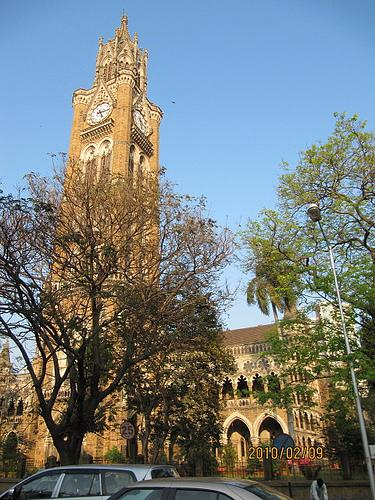Identify the main objects visible in the image and their colors. A blue sky with white clouds, a large tree to the right, a clock tower with a brown clock, a man wearing a white shirt, a red and white sign with the number 25, silver cars and a brick wall in front of a building. Describe any numbers present in the image and their context. There is the number 25 on a red and white sign and the date 20100209, which is a date stamp on the picture. What is the main action taking place in the image? Include the subject and their activity. A man in a white shirt is bending down in front of a building, near a sign with the number 25. Describe the tree that appears in the image, focusing on its position and size. There is a large tree to the right of the image, partially visible with a thick stem. Point out three architectural elements in the image and their respective colors. The clock tower is brown, the brick wall is red and the large arches on the building are gray. How would you describe the weather in this image? The weather seems to be pleasant, with a blue sky filled with white clouds. What color is the shirt worn by the man in the image? The man is wearing a white shirt. Describe the scene captured in the image focusing on the background elements. The image shows a blue sky with white clouds, a large tree beside a building, and the roof of the building. There is also a clock tower with a clock and a date stamp. From the provided information, what is the date mentioned in the image? The date mentioned in the image is 20100209. Read the text visible on the image at position X:247 Y:447 Width:77 Height:77. The date is 20100209. What is the color of the man's shirt at X:310 Y:477 Width:15 Height:15? White Explain the relationship between the clock and brick wall in the picture. The clock is on top of the building with a brick wall in front of it. Describe one significant detail that is mentioned about the cars in the image. These cars are silver. Describe any anomalies or unusual elements in the image. There are no significant anomalies or unusual elements. Where is the number "25" mentioned in the image? The number 25 is in red on the sign at X:121 Y:424 Width:10 Height:10. How would you describe the scene in this image? A street scene with cars driving by, a clock tower, a tall street lamp, and trees. Is there a person in the image? If yes, what are they doing? Yes, there is a man in a white shirt bending down in front of the building. Predict the interaction happening between the cars and the street lamp. The cars are driving past the tall street lamp. What objects can be seen interacting with the building in the background? Large tree beside building, cars driving by, and a person below the date. Point out the primary sentiment conveyed in the image. The primary sentiment conveyed is calm and serene. Which object has an attribute related to the date in the image? Date stamp on picture at X:237 Y:438 Width:109 Height:109. Identify the sentence that describes the object at X:85 Y:85 Width:21 Height:21. Clock What color is the large tree at position X:296 Y:116 Width:71 Height:71? Cannot answer, color information not available. Determine the quality of the image. The image has a high resolution and clear quality. In the image, how many different positions contain white clouds in a blue sky? There are 15 different positions. Is there any visible text in the image? If yes, where is it located? Yes, there is a date (20100209) at position X:247 Y:447 Width:77 Height:77. What do the numbers in the coordinates X:232 Y:432 Width:105 Height:105 signify? Numbers in the shot. 